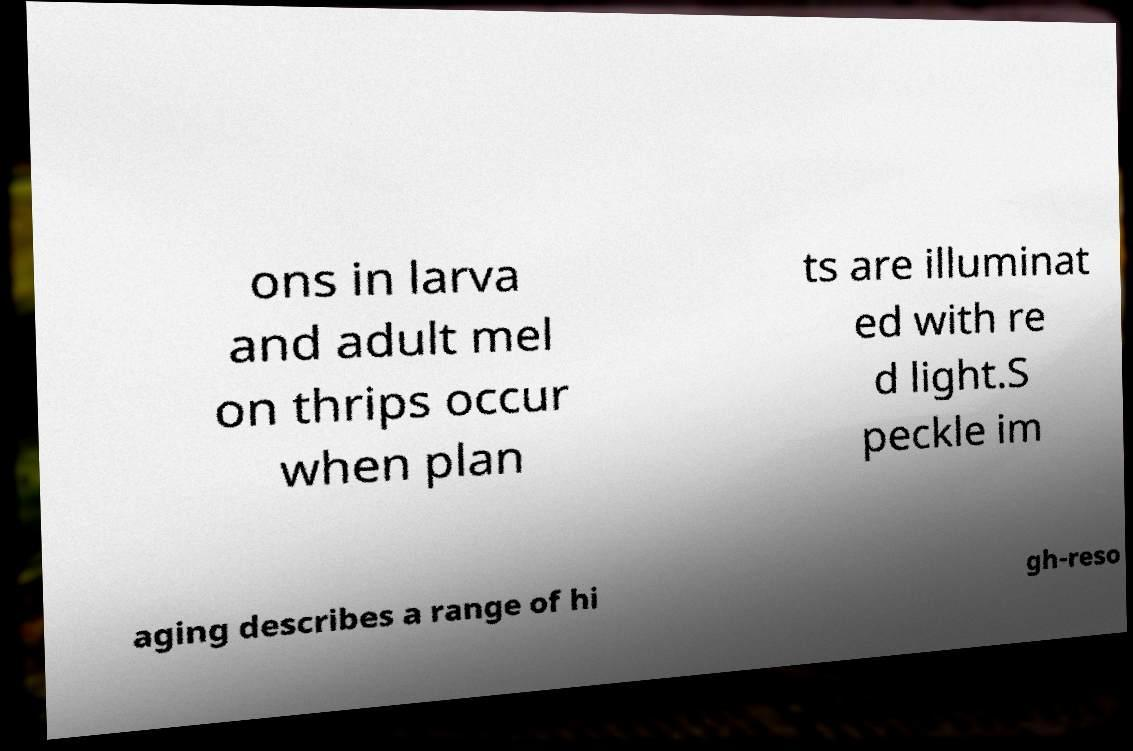What messages or text are displayed in this image? I need them in a readable, typed format. ons in larva and adult mel on thrips occur when plan ts are illuminat ed with re d light.S peckle im aging describes a range of hi gh-reso 